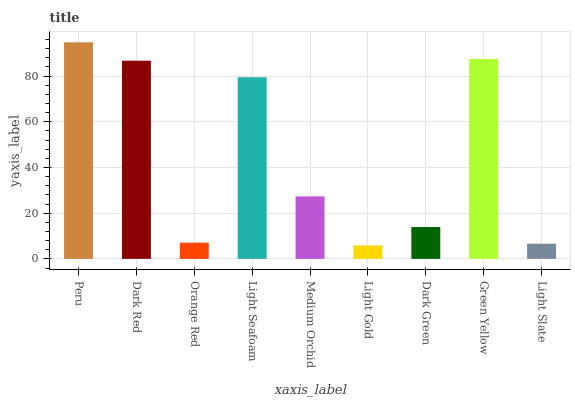Is Dark Red the minimum?
Answer yes or no. No. Is Dark Red the maximum?
Answer yes or no. No. Is Peru greater than Dark Red?
Answer yes or no. Yes. Is Dark Red less than Peru?
Answer yes or no. Yes. Is Dark Red greater than Peru?
Answer yes or no. No. Is Peru less than Dark Red?
Answer yes or no. No. Is Medium Orchid the high median?
Answer yes or no. Yes. Is Medium Orchid the low median?
Answer yes or no. Yes. Is Orange Red the high median?
Answer yes or no. No. Is Orange Red the low median?
Answer yes or no. No. 